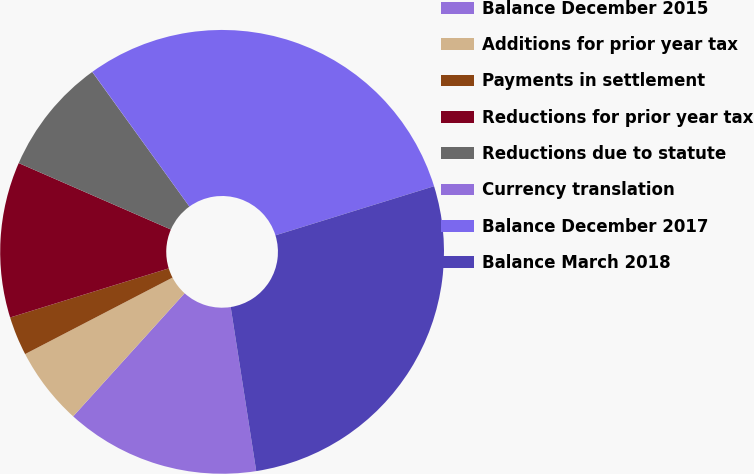Convert chart. <chart><loc_0><loc_0><loc_500><loc_500><pie_chart><fcel>Balance December 2015<fcel>Additions for prior year tax<fcel>Payments in settlement<fcel>Reductions for prior year tax<fcel>Reductions due to statute<fcel>Currency translation<fcel>Balance December 2017<fcel>Balance March 2018<nl><fcel>14.17%<fcel>5.67%<fcel>2.84%<fcel>11.33%<fcel>8.5%<fcel>0.01%<fcel>30.16%<fcel>27.32%<nl></chart> 